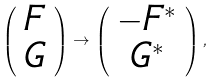Convert formula to latex. <formula><loc_0><loc_0><loc_500><loc_500>\left ( \begin{array} { c } F \\ G \end{array} \right ) \to \left ( \begin{array} { c } - F ^ { * } \\ G ^ { * } \end{array} \right ) ,</formula> 